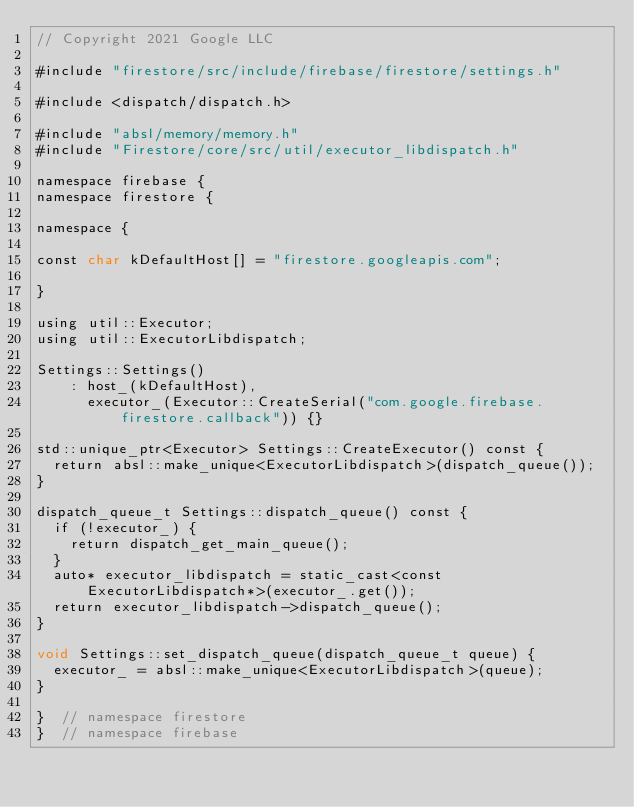Convert code to text. <code><loc_0><loc_0><loc_500><loc_500><_ObjectiveC_>// Copyright 2021 Google LLC

#include "firestore/src/include/firebase/firestore/settings.h"

#include <dispatch/dispatch.h>

#include "absl/memory/memory.h"
#include "Firestore/core/src/util/executor_libdispatch.h"

namespace firebase {
namespace firestore {

namespace {

const char kDefaultHost[] = "firestore.googleapis.com";

}

using util::Executor;
using util::ExecutorLibdispatch;

Settings::Settings()
    : host_(kDefaultHost),
      executor_(Executor::CreateSerial("com.google.firebase.firestore.callback")) {}

std::unique_ptr<Executor> Settings::CreateExecutor() const {
  return absl::make_unique<ExecutorLibdispatch>(dispatch_queue());
}

dispatch_queue_t Settings::dispatch_queue() const {
  if (!executor_) {
    return dispatch_get_main_queue();
  }
  auto* executor_libdispatch = static_cast<const ExecutorLibdispatch*>(executor_.get());
  return executor_libdispatch->dispatch_queue();
}

void Settings::set_dispatch_queue(dispatch_queue_t queue) {
  executor_ = absl::make_unique<ExecutorLibdispatch>(queue);
}

}  // namespace firestore
}  // namespace firebase
</code> 